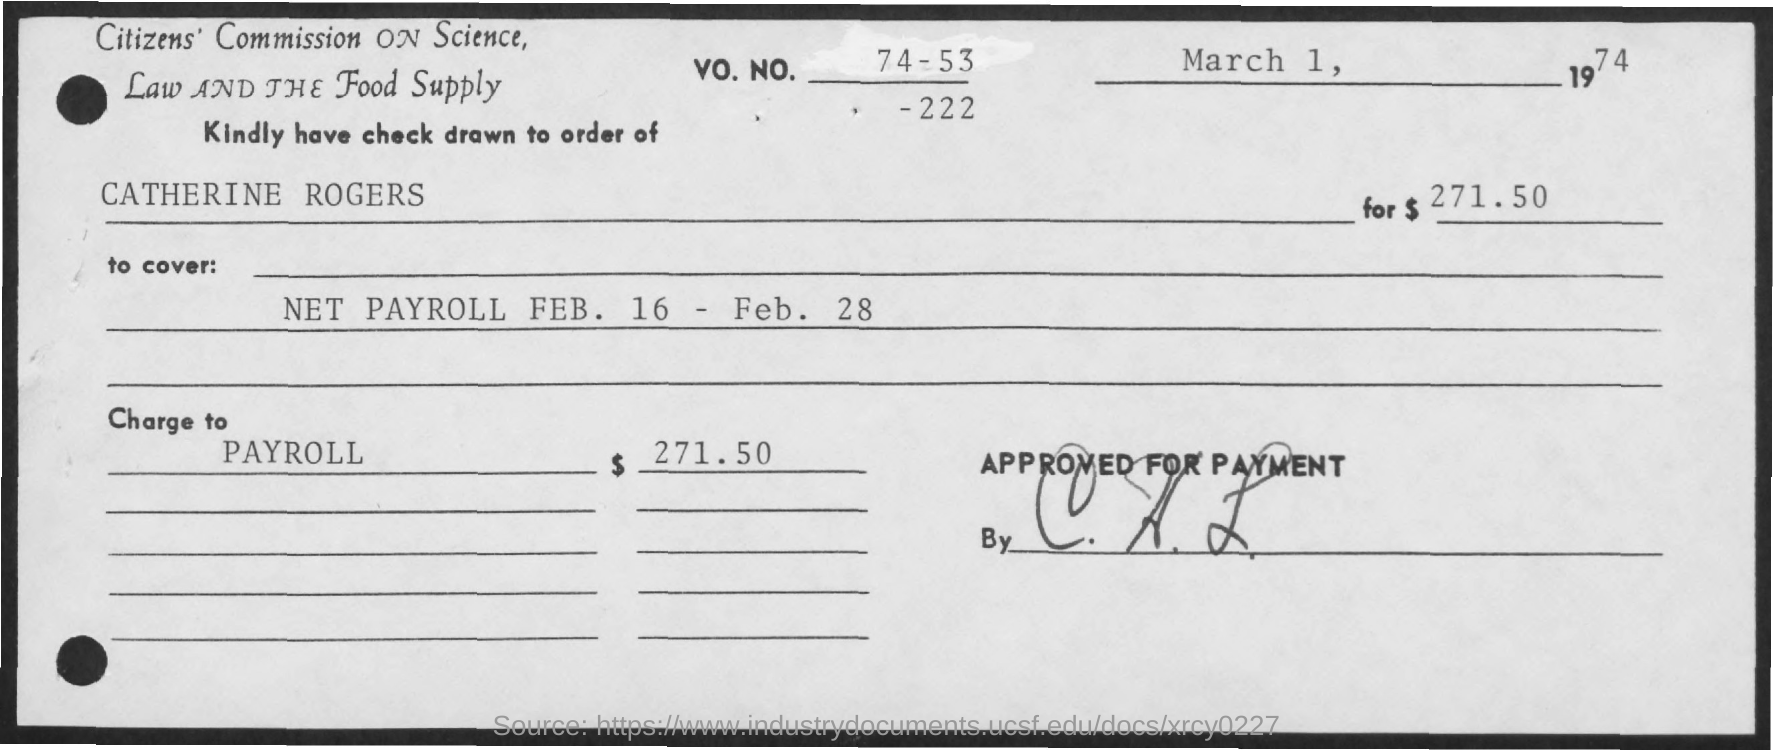What is the amount mentioned here?
Your answer should be very brief. $ 271.50. This check has to be drawn to order of who?
Ensure brevity in your answer.  Catherine Rogers. What is the date mentioned at the top-right?
Offer a terse response. March 1, 1974. What is this check charged to?
Make the answer very short. PAYROLL. 